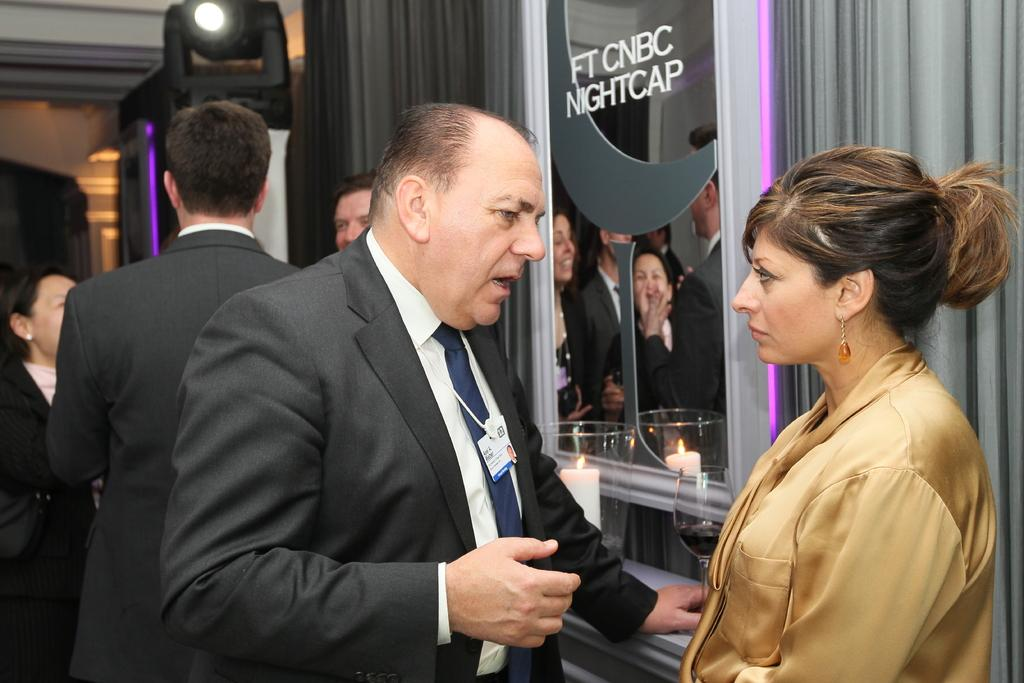How many people are in the image? There is a group of people standing in the image. What object in the image can be used for reflection? There is a mirror in the image. What type of glass is visible in the image? There is a wine glass in the image. What is the candle placed in within the image? There is a candle in a glass in the image. What type of window treatment is present in the image? There are curtains in the image. What type of lighting is present in the image? There is a focus light in the image. What is the topic of the argument taking place in the image? There is no argument present in the image; it features a group of people and various objects. What type of protest is being held in the image? There is no protest present in the image; it features a group of people and various objects. 